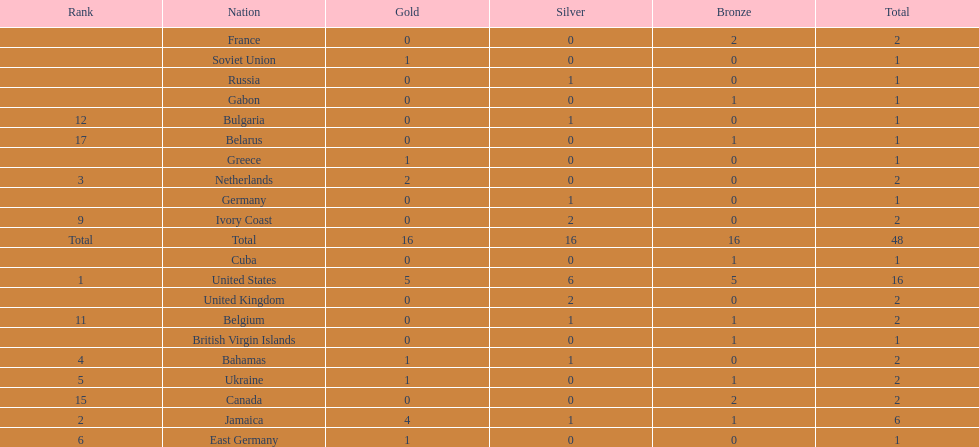How many nations won more than one silver medal? 3. 